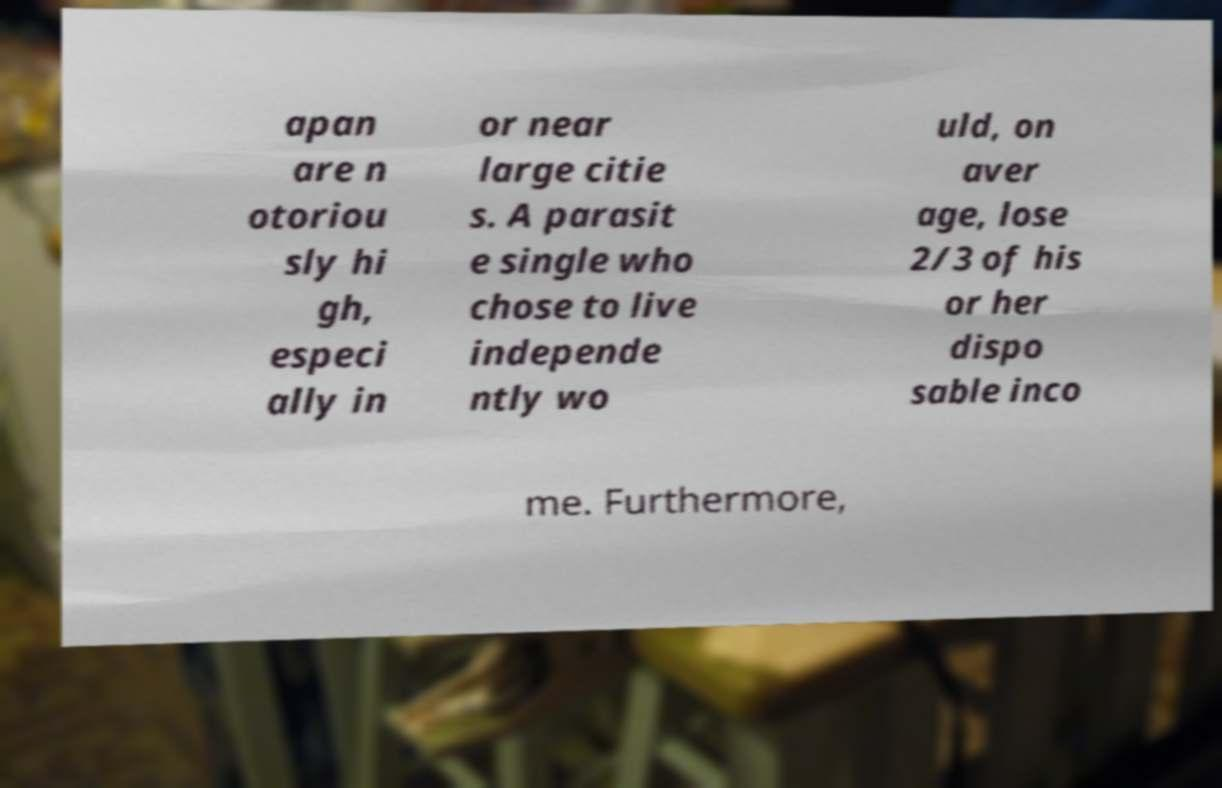There's text embedded in this image that I need extracted. Can you transcribe it verbatim? apan are n otoriou sly hi gh, especi ally in or near large citie s. A parasit e single who chose to live independe ntly wo uld, on aver age, lose 2/3 of his or her dispo sable inco me. Furthermore, 